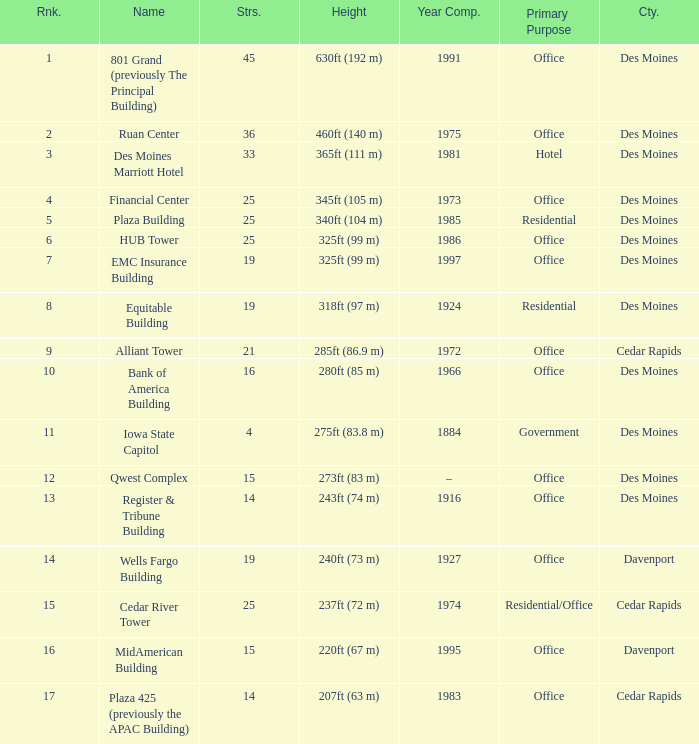What is the total stories that rank number 10? 1.0. 